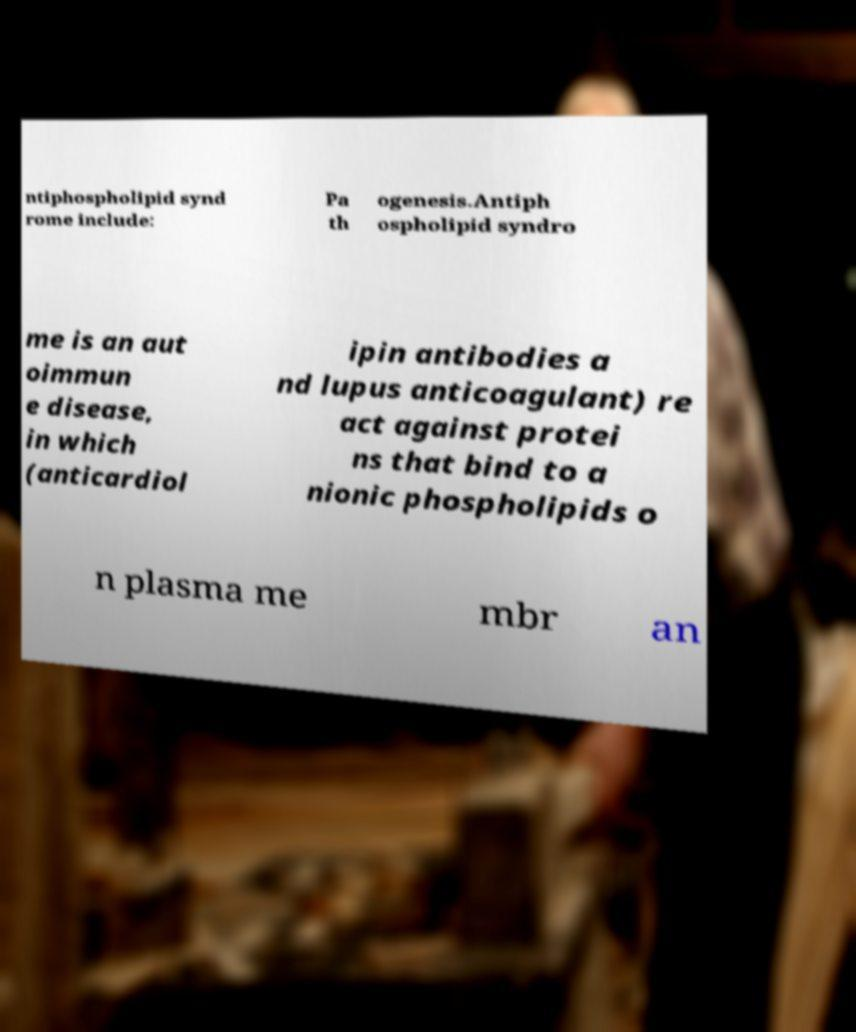Can you accurately transcribe the text from the provided image for me? ntiphospholipid synd rome include: Pa th ogenesis.Antiph ospholipid syndro me is an aut oimmun e disease, in which (anticardiol ipin antibodies a nd lupus anticoagulant) re act against protei ns that bind to a nionic phospholipids o n plasma me mbr an 